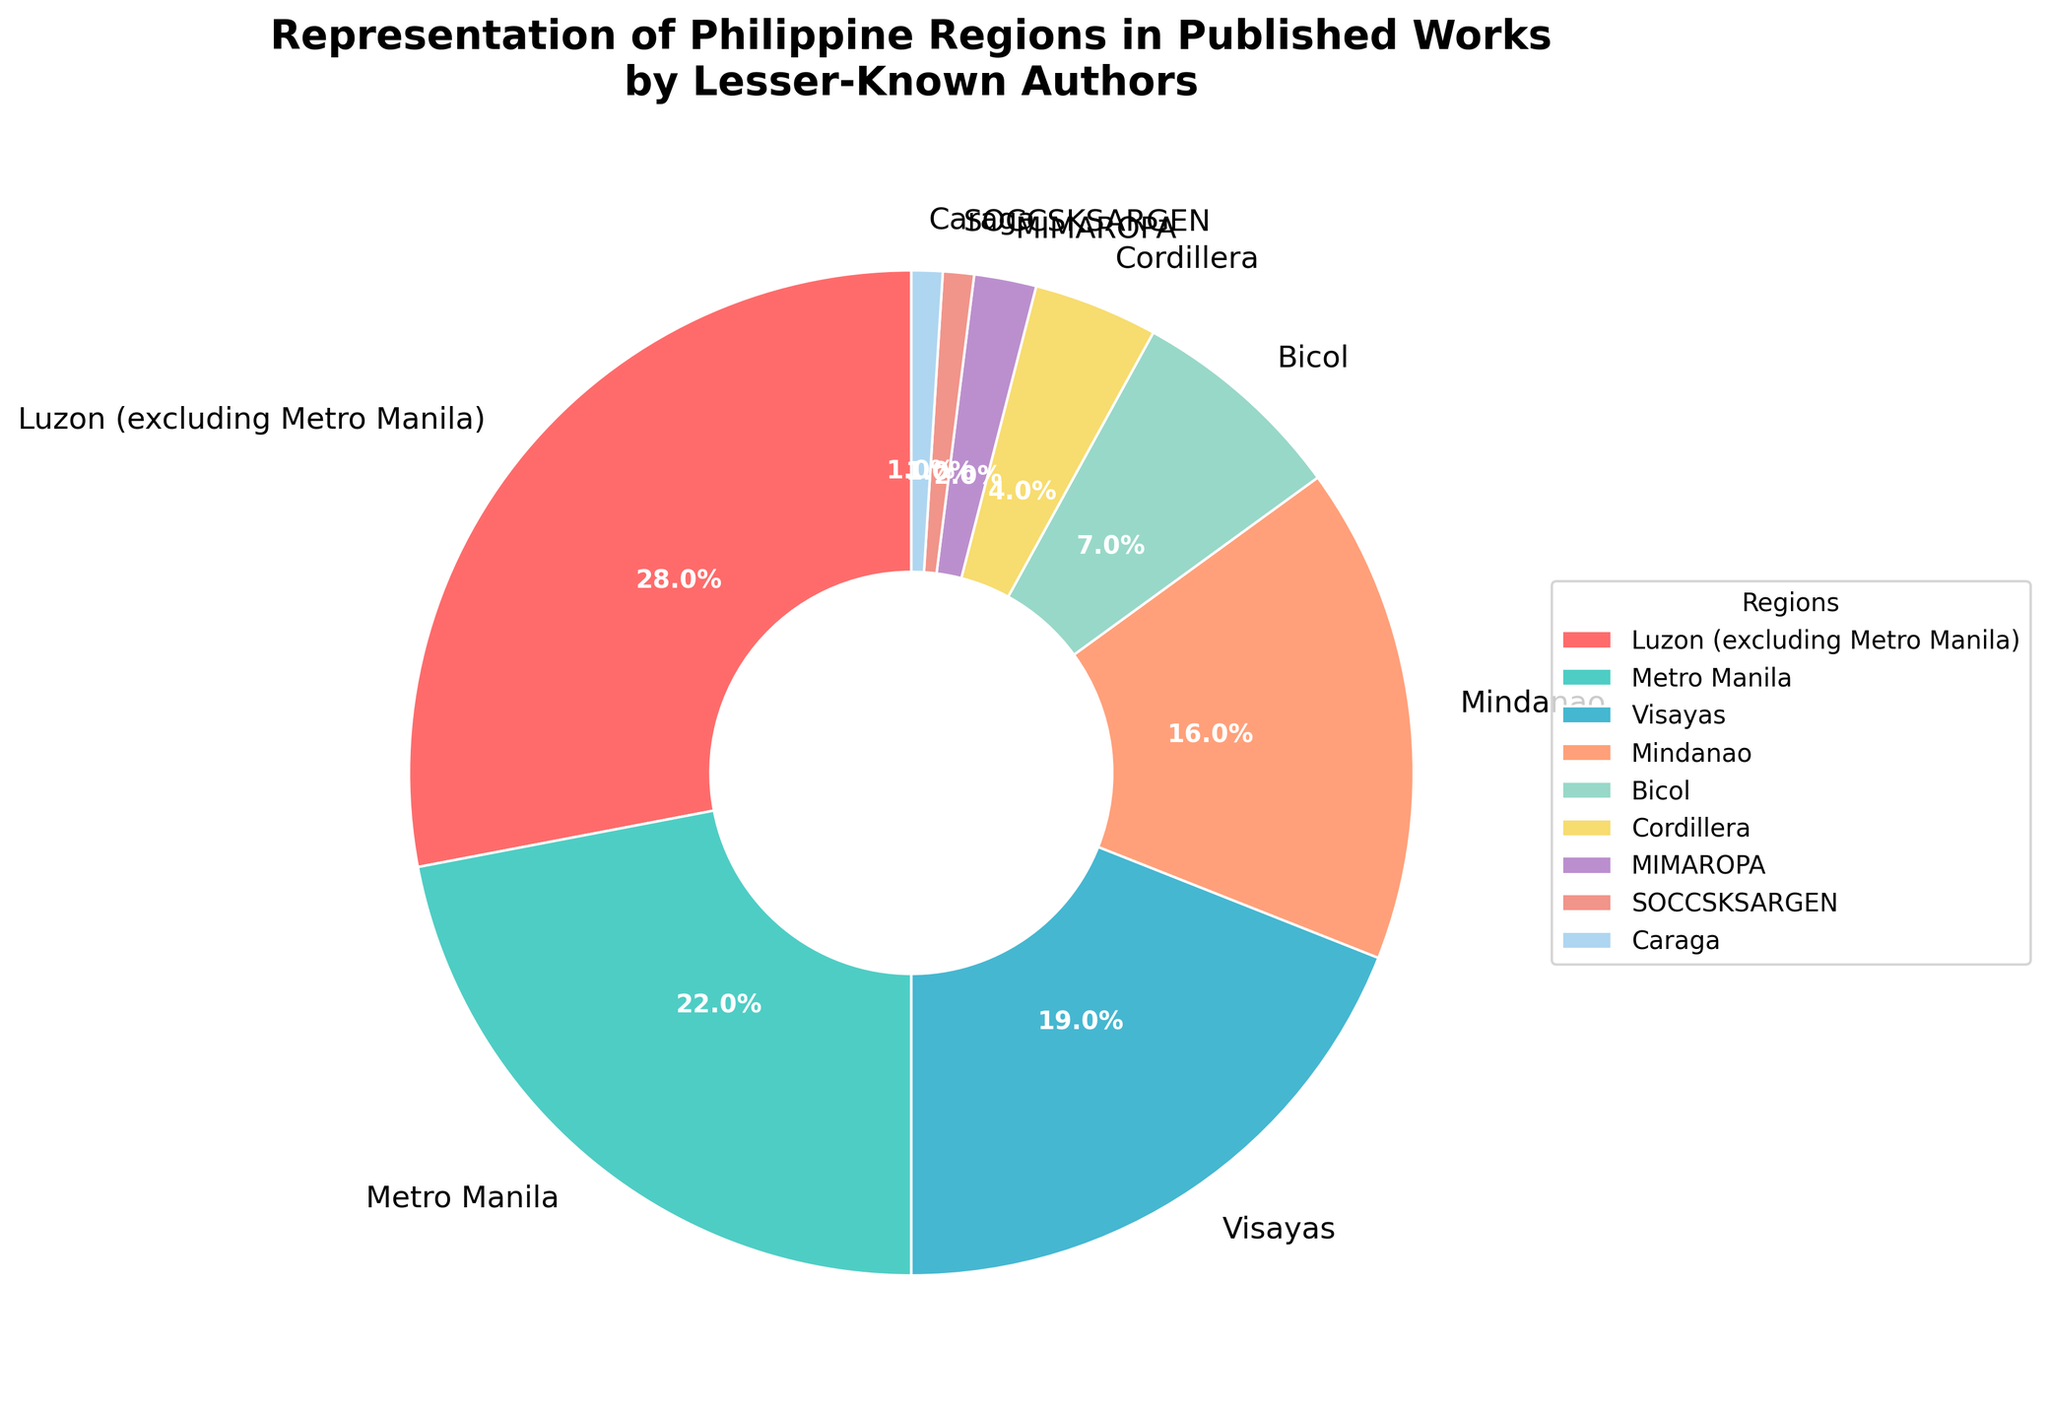Which region has the highest representation in published works by lesser-known authors? Luzon (excluding Metro Manila) has the highest representation at 28%.
Answer: Luzon (excluding Metro Manila) Which regions have less than 5% representation in published works? Cordillera, MIMAROPA, SOCCSKSARGEN, and Caraga have less than 5% representation, as their percentages are 4%, 2%, 1%, and 1% respectively.
Answer: Cordillera, MIMAROPA, SOCCSKSARGEN, Caraga What is the combined percentage of Visayas and Mindanao regions in published works? Visayas has 19% and Mindanao has 16%, so their combined percentage is 19% + 16% = 35%.
Answer: 35% How much more representation does Metro Manila have compared to Bicol? Metro Manila has 22% and Bicol has 7%, so Metro Manila has 22% - 7% = 15% more representation.
Answer: 15% Which region has the smallest representation in published works by lesser-known authors? SOCCSKSARGEN and Caraga each have the smallest representation at 1%.
Answer: SOCCSKSARGEN, Caraga Compare the combined representation of Luzon (excluding Metro Manila) and Metro Manila to the combined representation of Visayas and Mindanao. Which is higher? The combined representation of Luzon and Metro Manila is 28% + 22% = 50%, and that of Visayas and Mindanao is 19% + 16% = 35%. Luzon and Metro Manila have a higher combined representation.
Answer: Luzon and Metro Manila How does the representation of the Bicol region compare to that of the Cordillera region? Bicol has 7% representation while Cordillera has 4%, so Bicol has 3% more representation than Cordillera.
Answer: Bicol has 3% more What is the total percentage representation of regions with less than 10% in published works? Regions with less than 10% representation are Bicol, Cordillera, MIMAROPA, SOCCSKSARGEN, and Caraga; summing their percentages gives 7% + 4% + 2% + 1% + 1% = 15%.
Answer: 15% What is the average percentage representation of the regions Luzon (excluding Metro Manila), Metro Manila, and Visayas? Luzon (excluding Metro Manila) has 28%, Metro Manila has 22%, and Visayas has 19%. The average is (28% + 22% + 19%) / 3 = 69% / 3 = 23%.
Answer: 23% What visual attribute of the pie chart makes it easy to identify which regions have the most and least representation? The size of the wedges in the pie chart makes it easy to identify which regions have the most and least representation. Larger wedges represent higher percentages and smaller wedges represent lower percentages.
Answer: Size of the wedges 